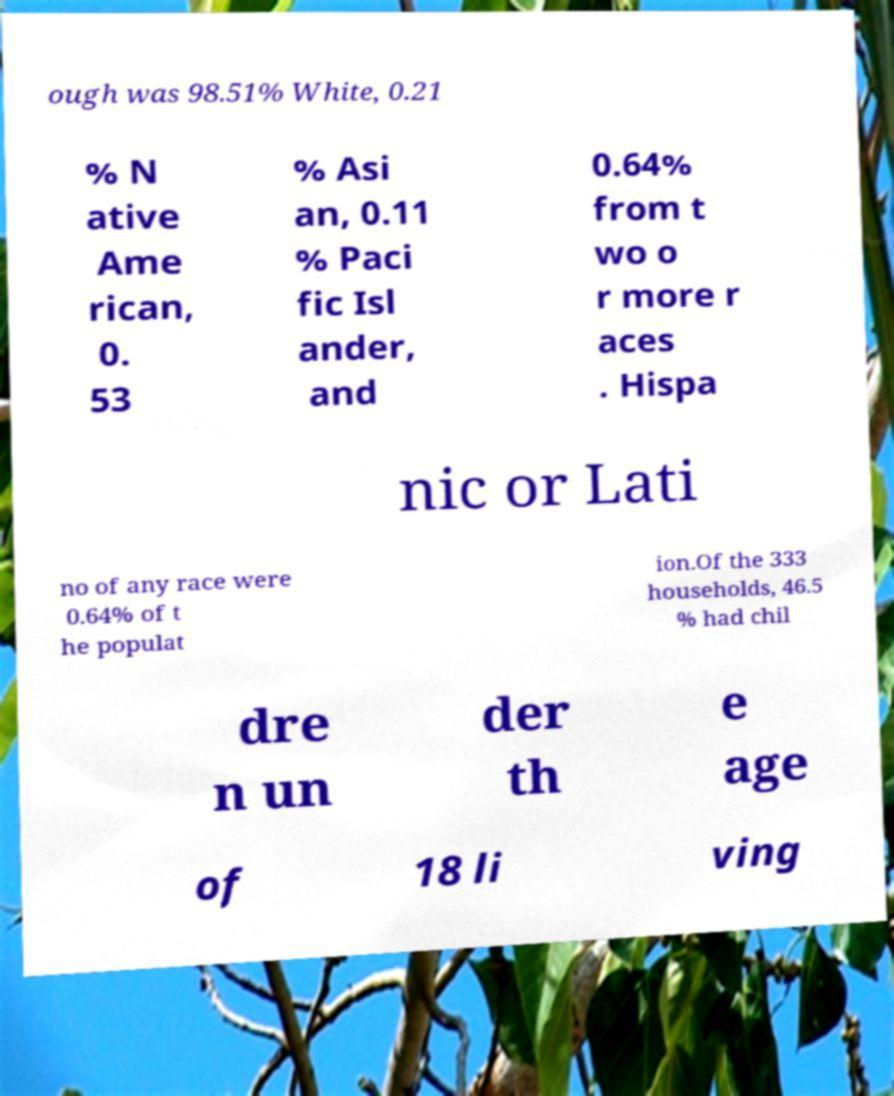There's text embedded in this image that I need extracted. Can you transcribe it verbatim? ough was 98.51% White, 0.21 % N ative Ame rican, 0. 53 % Asi an, 0.11 % Paci fic Isl ander, and 0.64% from t wo o r more r aces . Hispa nic or Lati no of any race were 0.64% of t he populat ion.Of the 333 households, 46.5 % had chil dre n un der th e age of 18 li ving 